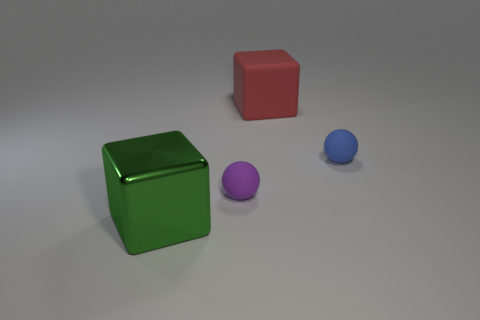Does the big object to the right of the small purple thing have the same shape as the metal thing?
Provide a short and direct response. Yes. Do the big metallic thing and the small purple matte thing have the same shape?
Ensure brevity in your answer.  No. What number of shiny things are either tiny blue spheres or purple objects?
Your answer should be compact. 0. Is the green metal cube the same size as the blue rubber object?
Provide a succinct answer. No. What number of things are large green metallic blocks or objects left of the blue object?
Provide a succinct answer. 3. What material is the block that is the same size as the red matte thing?
Offer a very short reply. Metal. What material is the thing that is both left of the blue rubber object and to the right of the purple thing?
Keep it short and to the point. Rubber. There is a large block that is behind the blue ball; is there a large matte cube that is behind it?
Your answer should be very brief. No. How big is the thing that is right of the big green metallic object and on the left side of the large red block?
Give a very brief answer. Small. How many green things are matte balls or matte cubes?
Make the answer very short. 0. 